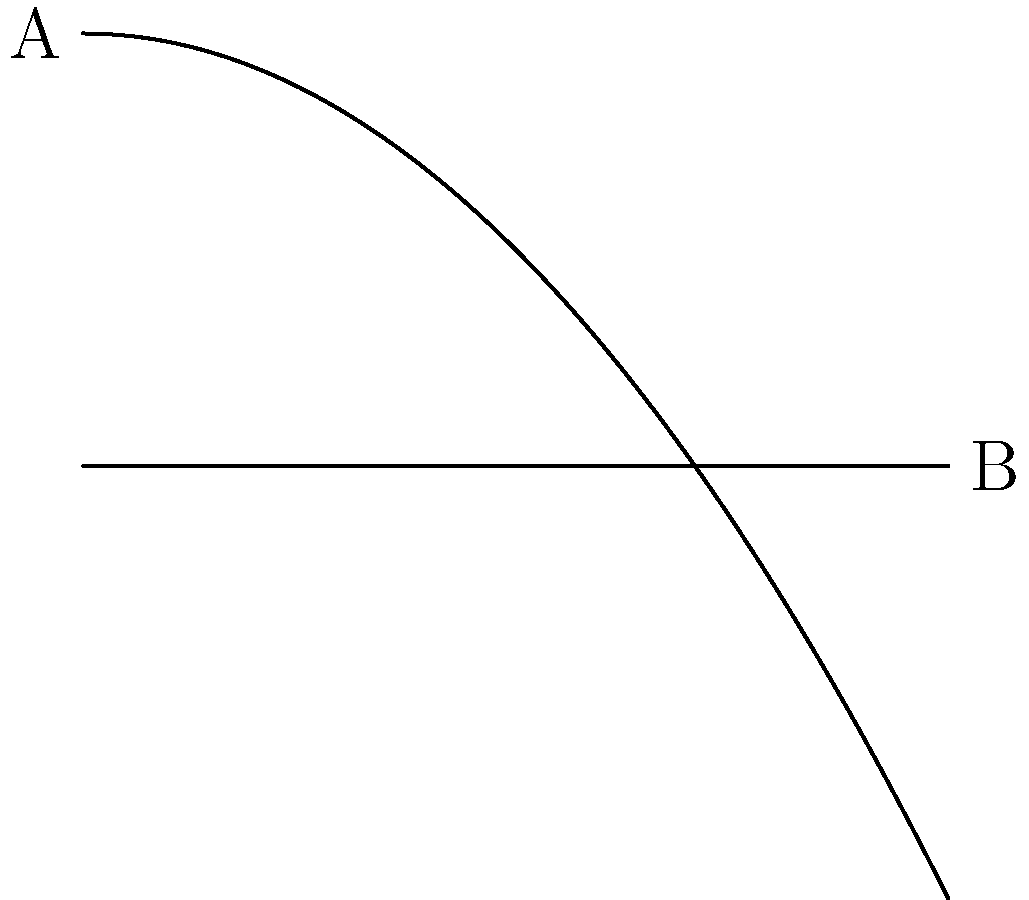Remember those hilly paths on campus? A student of mass 70 kg walks from point A to point B along a path that can be modeled by the equation $h(x) = 10 - 0.05x^2$, where $h$ is the height in meters and $x$ is the horizontal distance in meters. What is the change in the student's gravitational potential energy from point A to point B? (Use $g = 9.8$ m/s²) To solve this problem, let's follow these steps:

1) The gravitational potential energy is given by the equation:
   $$PE = mgh$$
   where $m$ is mass, $g$ is acceleration due to gravity, and $h$ is height.

2) We need to find the change in potential energy, which is:
   $$\Delta PE = PE_{final} - PE_{initial}$$

3) At point A:
   $h_A = 10$ m
   $$PE_A = 70 \times 9.8 \times 10 = 6860 \text{ J}$$

4) At point B:
   $h_B = 0$ m
   $$PE_B = 70 \times 9.8 \times 0 = 0 \text{ J}$$

5) Therefore, the change in potential energy is:
   $$\Delta PE = PE_B - PE_A = 0 - 6860 = -6860 \text{ J}$$

The negative sign indicates that the potential energy decreased as the student walked downhill.
Answer: -6860 J 